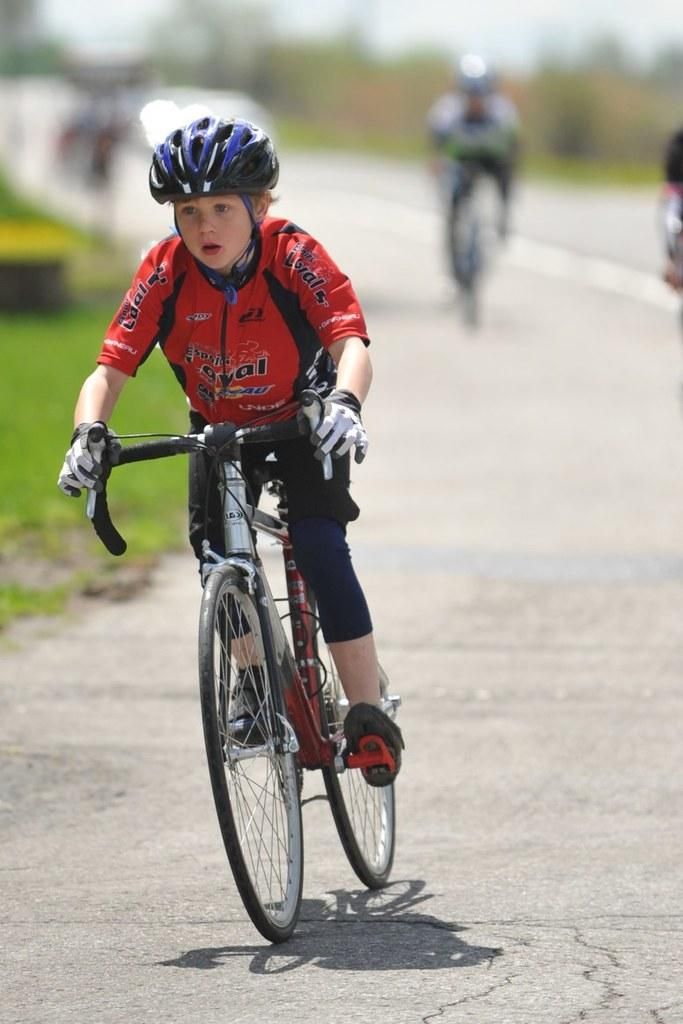Who is the main subject in the image? There is a boy in the image. What is the boy doing in the image? The boy is riding a bicycle. What is the boy wearing in the image? The boy is wearing a red dress and a helmet. Can you describe the background of the image? The background of the image is blurred. What type of wine is the boy holding while riding the bicycle in the image? There is no wine present in the image; the boy is wearing a helmet and riding a bicycle. 